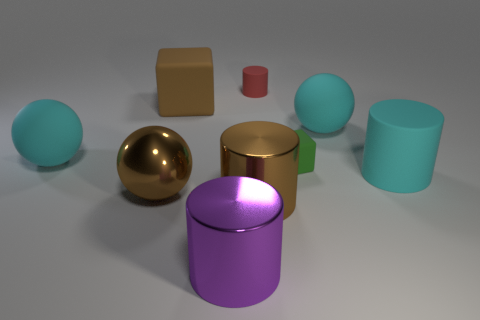Subtract all cyan cubes. How many cyan spheres are left? 2 Subtract all large cyan balls. How many balls are left? 1 Add 1 large cyan matte cylinders. How many objects exist? 10 Subtract all brown cylinders. How many cylinders are left? 3 Subtract all cylinders. How many objects are left? 5 Subtract all red balls. Subtract all blue cubes. How many balls are left? 3 Subtract 0 gray spheres. How many objects are left? 9 Subtract all large purple things. Subtract all rubber cylinders. How many objects are left? 6 Add 1 tiny green blocks. How many tiny green blocks are left? 2 Add 8 cubes. How many cubes exist? 10 